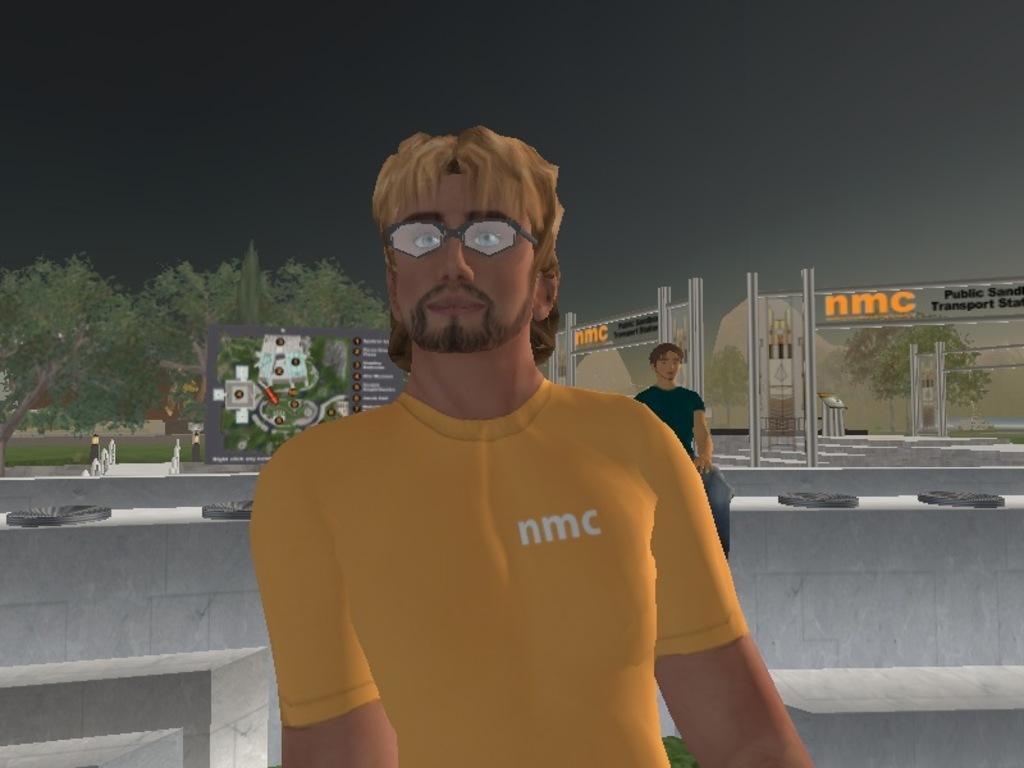Please provide a concise description of this image. This is an animated image. In this image we can see a man wearing glasses. On the backside we can see a person sitting on a wall, some buildings with sign boards and some text on it, trees, grass and the sky. 